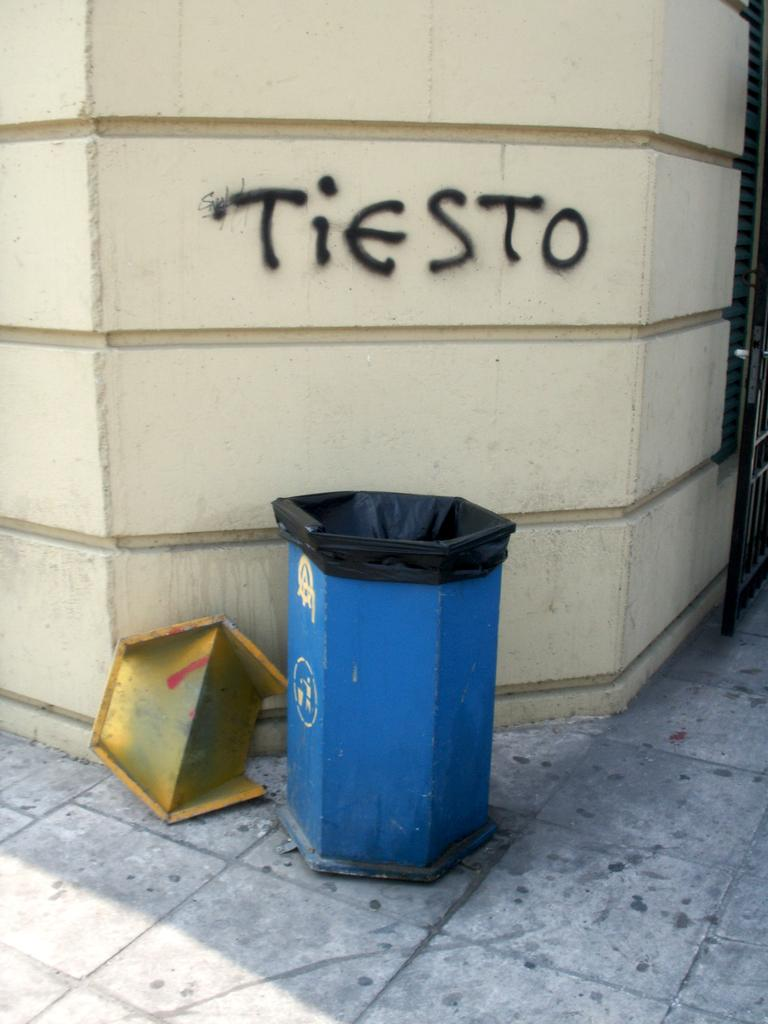<image>
Describe the image concisely. A trashcan sits in front of a wall that was tagged Tiesto. 